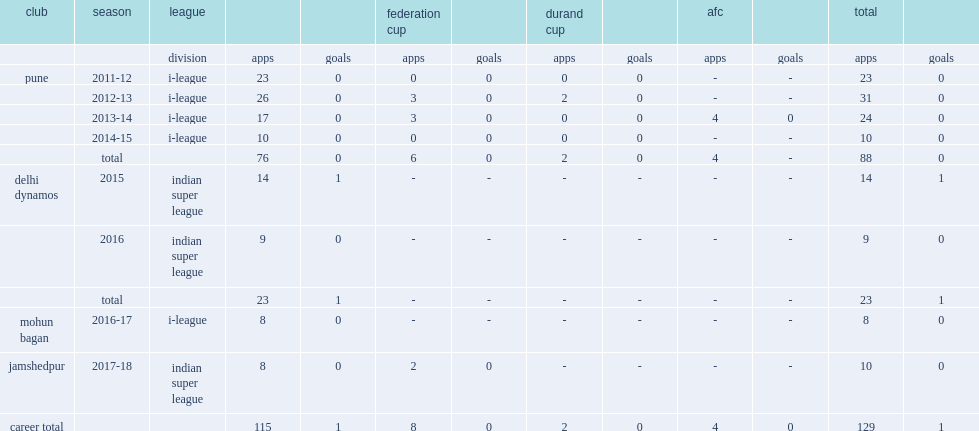Which league did anas play for jamshedupr in the 2017-18 seaon? Indian super league. I'm looking to parse the entire table for insights. Could you assist me with that? {'header': ['club', 'season', 'league', '', '', 'federation cup', '', 'durand cup', '', 'afc', '', 'total', ''], 'rows': [['', '', 'division', 'apps', 'goals', 'apps', 'goals', 'apps', 'goals', 'apps', 'goals', 'apps', 'goals'], ['pune', '2011-12', 'i-league', '23', '0', '0', '0', '0', '0', '-', '-', '23', '0'], ['', '2012-13', 'i-league', '26', '0', '3', '0', '2', '0', '-', '-', '31', '0'], ['', '2013-14', 'i-league', '17', '0', '3', '0', '0', '0', '4', '0', '24', '0'], ['', '2014-15', 'i-league', '10', '0', '0', '0', '0', '0', '-', '-', '10', '0'], ['', 'total', '', '76', '0', '6', '0', '2', '0', '4', '-', '88', '0'], ['delhi dynamos', '2015', 'indian super league', '14', '1', '-', '-', '-', '-', '-', '-', '14', '1'], ['', '2016', 'indian super league', '9', '0', '-', '-', '-', '-', '-', '-', '9', '0'], ['', 'total', '', '23', '1', '-', '-', '-', '-', '-', '-', '23', '1'], ['mohun bagan', '2016-17', 'i-league', '8', '0', '-', '-', '-', '-', '-', '-', '8', '0'], ['jamshedpur', '2017-18', 'indian super league', '8', '0', '2', '0', '-', '-', '-', '-', '10', '0'], ['career total', '', '', '115', '1', '8', '0', '2', '0', '4', '0', '129', '1']]} 